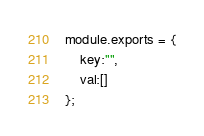<code> <loc_0><loc_0><loc_500><loc_500><_JavaScript_>module.exports = {
    key:"",
    val:[]
};</code> 